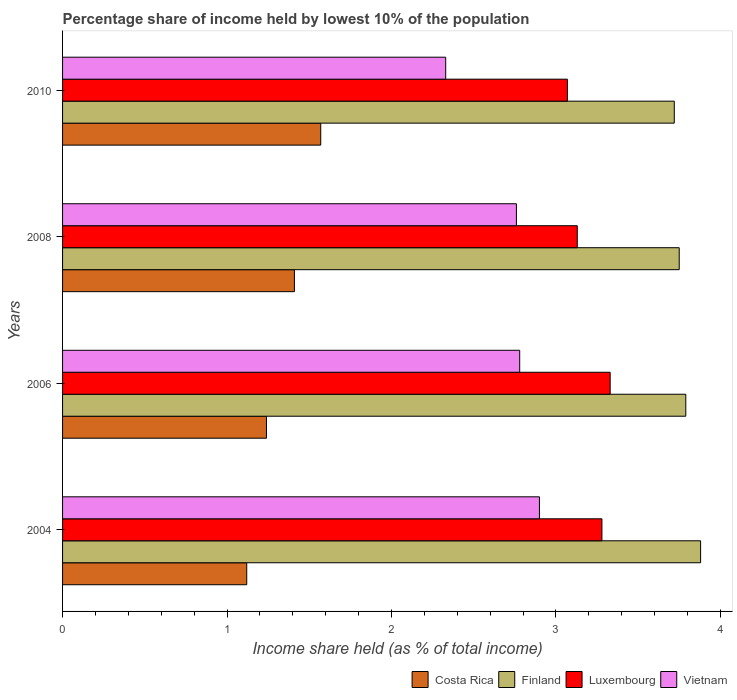How many different coloured bars are there?
Your answer should be very brief. 4. How many groups of bars are there?
Keep it short and to the point. 4. Are the number of bars per tick equal to the number of legend labels?
Your answer should be compact. Yes. Are the number of bars on each tick of the Y-axis equal?
Provide a short and direct response. Yes. How many bars are there on the 1st tick from the bottom?
Keep it short and to the point. 4. What is the label of the 2nd group of bars from the top?
Make the answer very short. 2008. What is the percentage share of income held by lowest 10% of the population in Costa Rica in 2004?
Provide a succinct answer. 1.12. Across all years, what is the maximum percentage share of income held by lowest 10% of the population in Vietnam?
Make the answer very short. 2.9. Across all years, what is the minimum percentage share of income held by lowest 10% of the population in Costa Rica?
Offer a terse response. 1.12. What is the total percentage share of income held by lowest 10% of the population in Finland in the graph?
Make the answer very short. 15.14. What is the difference between the percentage share of income held by lowest 10% of the population in Finland in 2006 and that in 2010?
Make the answer very short. 0.07. What is the difference between the percentage share of income held by lowest 10% of the population in Luxembourg in 2004 and the percentage share of income held by lowest 10% of the population in Finland in 2008?
Keep it short and to the point. -0.47. What is the average percentage share of income held by lowest 10% of the population in Luxembourg per year?
Ensure brevity in your answer.  3.2. In the year 2004, what is the difference between the percentage share of income held by lowest 10% of the population in Finland and percentage share of income held by lowest 10% of the population in Luxembourg?
Offer a terse response. 0.6. What is the ratio of the percentage share of income held by lowest 10% of the population in Costa Rica in 2008 to that in 2010?
Your answer should be very brief. 0.9. Is the percentage share of income held by lowest 10% of the population in Costa Rica in 2004 less than that in 2010?
Ensure brevity in your answer.  Yes. What is the difference between the highest and the second highest percentage share of income held by lowest 10% of the population in Luxembourg?
Your response must be concise. 0.05. What is the difference between the highest and the lowest percentage share of income held by lowest 10% of the population in Costa Rica?
Ensure brevity in your answer.  0.45. Is the sum of the percentage share of income held by lowest 10% of the population in Luxembourg in 2004 and 2008 greater than the maximum percentage share of income held by lowest 10% of the population in Vietnam across all years?
Your answer should be very brief. Yes. What does the 2nd bar from the bottom in 2004 represents?
Give a very brief answer. Finland. How many bars are there?
Your answer should be compact. 16. Are all the bars in the graph horizontal?
Your answer should be very brief. Yes. How many years are there in the graph?
Offer a very short reply. 4. Does the graph contain any zero values?
Your answer should be very brief. No. Does the graph contain grids?
Provide a short and direct response. No. How are the legend labels stacked?
Offer a terse response. Horizontal. What is the title of the graph?
Your answer should be very brief. Percentage share of income held by lowest 10% of the population. What is the label or title of the X-axis?
Your answer should be very brief. Income share held (as % of total income). What is the Income share held (as % of total income) of Costa Rica in 2004?
Give a very brief answer. 1.12. What is the Income share held (as % of total income) of Finland in 2004?
Provide a succinct answer. 3.88. What is the Income share held (as % of total income) in Luxembourg in 2004?
Make the answer very short. 3.28. What is the Income share held (as % of total income) in Costa Rica in 2006?
Your answer should be compact. 1.24. What is the Income share held (as % of total income) in Finland in 2006?
Make the answer very short. 3.79. What is the Income share held (as % of total income) of Luxembourg in 2006?
Your answer should be very brief. 3.33. What is the Income share held (as % of total income) of Vietnam in 2006?
Provide a short and direct response. 2.78. What is the Income share held (as % of total income) of Costa Rica in 2008?
Provide a succinct answer. 1.41. What is the Income share held (as % of total income) in Finland in 2008?
Your response must be concise. 3.75. What is the Income share held (as % of total income) in Luxembourg in 2008?
Provide a short and direct response. 3.13. What is the Income share held (as % of total income) of Vietnam in 2008?
Ensure brevity in your answer.  2.76. What is the Income share held (as % of total income) of Costa Rica in 2010?
Your answer should be compact. 1.57. What is the Income share held (as % of total income) in Finland in 2010?
Your answer should be compact. 3.72. What is the Income share held (as % of total income) in Luxembourg in 2010?
Provide a succinct answer. 3.07. What is the Income share held (as % of total income) in Vietnam in 2010?
Ensure brevity in your answer.  2.33. Across all years, what is the maximum Income share held (as % of total income) in Costa Rica?
Provide a short and direct response. 1.57. Across all years, what is the maximum Income share held (as % of total income) in Finland?
Make the answer very short. 3.88. Across all years, what is the maximum Income share held (as % of total income) of Luxembourg?
Provide a succinct answer. 3.33. Across all years, what is the maximum Income share held (as % of total income) of Vietnam?
Your answer should be very brief. 2.9. Across all years, what is the minimum Income share held (as % of total income) in Costa Rica?
Give a very brief answer. 1.12. Across all years, what is the minimum Income share held (as % of total income) in Finland?
Ensure brevity in your answer.  3.72. Across all years, what is the minimum Income share held (as % of total income) of Luxembourg?
Provide a short and direct response. 3.07. Across all years, what is the minimum Income share held (as % of total income) of Vietnam?
Ensure brevity in your answer.  2.33. What is the total Income share held (as % of total income) in Costa Rica in the graph?
Ensure brevity in your answer.  5.34. What is the total Income share held (as % of total income) of Finland in the graph?
Ensure brevity in your answer.  15.14. What is the total Income share held (as % of total income) of Luxembourg in the graph?
Provide a short and direct response. 12.81. What is the total Income share held (as % of total income) in Vietnam in the graph?
Give a very brief answer. 10.77. What is the difference between the Income share held (as % of total income) in Costa Rica in 2004 and that in 2006?
Offer a very short reply. -0.12. What is the difference between the Income share held (as % of total income) of Finland in 2004 and that in 2006?
Your answer should be very brief. 0.09. What is the difference between the Income share held (as % of total income) in Vietnam in 2004 and that in 2006?
Give a very brief answer. 0.12. What is the difference between the Income share held (as % of total income) in Costa Rica in 2004 and that in 2008?
Ensure brevity in your answer.  -0.29. What is the difference between the Income share held (as % of total income) of Finland in 2004 and that in 2008?
Provide a short and direct response. 0.13. What is the difference between the Income share held (as % of total income) in Luxembourg in 2004 and that in 2008?
Give a very brief answer. 0.15. What is the difference between the Income share held (as % of total income) of Vietnam in 2004 and that in 2008?
Offer a very short reply. 0.14. What is the difference between the Income share held (as % of total income) in Costa Rica in 2004 and that in 2010?
Ensure brevity in your answer.  -0.45. What is the difference between the Income share held (as % of total income) in Finland in 2004 and that in 2010?
Your answer should be very brief. 0.16. What is the difference between the Income share held (as % of total income) in Luxembourg in 2004 and that in 2010?
Offer a terse response. 0.21. What is the difference between the Income share held (as % of total income) of Vietnam in 2004 and that in 2010?
Your answer should be compact. 0.57. What is the difference between the Income share held (as % of total income) in Costa Rica in 2006 and that in 2008?
Your response must be concise. -0.17. What is the difference between the Income share held (as % of total income) of Costa Rica in 2006 and that in 2010?
Your answer should be compact. -0.33. What is the difference between the Income share held (as % of total income) of Finland in 2006 and that in 2010?
Your answer should be very brief. 0.07. What is the difference between the Income share held (as % of total income) of Luxembourg in 2006 and that in 2010?
Offer a terse response. 0.26. What is the difference between the Income share held (as % of total income) of Vietnam in 2006 and that in 2010?
Your answer should be very brief. 0.45. What is the difference between the Income share held (as % of total income) of Costa Rica in 2008 and that in 2010?
Your response must be concise. -0.16. What is the difference between the Income share held (as % of total income) of Finland in 2008 and that in 2010?
Offer a terse response. 0.03. What is the difference between the Income share held (as % of total income) in Vietnam in 2008 and that in 2010?
Ensure brevity in your answer.  0.43. What is the difference between the Income share held (as % of total income) of Costa Rica in 2004 and the Income share held (as % of total income) of Finland in 2006?
Make the answer very short. -2.67. What is the difference between the Income share held (as % of total income) in Costa Rica in 2004 and the Income share held (as % of total income) in Luxembourg in 2006?
Provide a short and direct response. -2.21. What is the difference between the Income share held (as % of total income) in Costa Rica in 2004 and the Income share held (as % of total income) in Vietnam in 2006?
Ensure brevity in your answer.  -1.66. What is the difference between the Income share held (as % of total income) in Finland in 2004 and the Income share held (as % of total income) in Luxembourg in 2006?
Provide a short and direct response. 0.55. What is the difference between the Income share held (as % of total income) of Finland in 2004 and the Income share held (as % of total income) of Vietnam in 2006?
Your answer should be compact. 1.1. What is the difference between the Income share held (as % of total income) in Luxembourg in 2004 and the Income share held (as % of total income) in Vietnam in 2006?
Give a very brief answer. 0.5. What is the difference between the Income share held (as % of total income) of Costa Rica in 2004 and the Income share held (as % of total income) of Finland in 2008?
Provide a short and direct response. -2.63. What is the difference between the Income share held (as % of total income) of Costa Rica in 2004 and the Income share held (as % of total income) of Luxembourg in 2008?
Ensure brevity in your answer.  -2.01. What is the difference between the Income share held (as % of total income) of Costa Rica in 2004 and the Income share held (as % of total income) of Vietnam in 2008?
Give a very brief answer. -1.64. What is the difference between the Income share held (as % of total income) of Finland in 2004 and the Income share held (as % of total income) of Vietnam in 2008?
Provide a succinct answer. 1.12. What is the difference between the Income share held (as % of total income) in Luxembourg in 2004 and the Income share held (as % of total income) in Vietnam in 2008?
Offer a terse response. 0.52. What is the difference between the Income share held (as % of total income) of Costa Rica in 2004 and the Income share held (as % of total income) of Luxembourg in 2010?
Offer a very short reply. -1.95. What is the difference between the Income share held (as % of total income) in Costa Rica in 2004 and the Income share held (as % of total income) in Vietnam in 2010?
Offer a terse response. -1.21. What is the difference between the Income share held (as % of total income) of Finland in 2004 and the Income share held (as % of total income) of Luxembourg in 2010?
Ensure brevity in your answer.  0.81. What is the difference between the Income share held (as % of total income) in Finland in 2004 and the Income share held (as % of total income) in Vietnam in 2010?
Your answer should be very brief. 1.55. What is the difference between the Income share held (as % of total income) of Costa Rica in 2006 and the Income share held (as % of total income) of Finland in 2008?
Your answer should be very brief. -2.51. What is the difference between the Income share held (as % of total income) of Costa Rica in 2006 and the Income share held (as % of total income) of Luxembourg in 2008?
Ensure brevity in your answer.  -1.89. What is the difference between the Income share held (as % of total income) of Costa Rica in 2006 and the Income share held (as % of total income) of Vietnam in 2008?
Your answer should be compact. -1.52. What is the difference between the Income share held (as % of total income) of Finland in 2006 and the Income share held (as % of total income) of Luxembourg in 2008?
Provide a short and direct response. 0.66. What is the difference between the Income share held (as % of total income) in Finland in 2006 and the Income share held (as % of total income) in Vietnam in 2008?
Provide a succinct answer. 1.03. What is the difference between the Income share held (as % of total income) of Luxembourg in 2006 and the Income share held (as % of total income) of Vietnam in 2008?
Offer a very short reply. 0.57. What is the difference between the Income share held (as % of total income) in Costa Rica in 2006 and the Income share held (as % of total income) in Finland in 2010?
Provide a succinct answer. -2.48. What is the difference between the Income share held (as % of total income) of Costa Rica in 2006 and the Income share held (as % of total income) of Luxembourg in 2010?
Give a very brief answer. -1.83. What is the difference between the Income share held (as % of total income) in Costa Rica in 2006 and the Income share held (as % of total income) in Vietnam in 2010?
Offer a very short reply. -1.09. What is the difference between the Income share held (as % of total income) in Finland in 2006 and the Income share held (as % of total income) in Luxembourg in 2010?
Provide a succinct answer. 0.72. What is the difference between the Income share held (as % of total income) in Finland in 2006 and the Income share held (as % of total income) in Vietnam in 2010?
Your answer should be very brief. 1.46. What is the difference between the Income share held (as % of total income) of Luxembourg in 2006 and the Income share held (as % of total income) of Vietnam in 2010?
Your answer should be compact. 1. What is the difference between the Income share held (as % of total income) of Costa Rica in 2008 and the Income share held (as % of total income) of Finland in 2010?
Offer a terse response. -2.31. What is the difference between the Income share held (as % of total income) of Costa Rica in 2008 and the Income share held (as % of total income) of Luxembourg in 2010?
Your answer should be very brief. -1.66. What is the difference between the Income share held (as % of total income) in Costa Rica in 2008 and the Income share held (as % of total income) in Vietnam in 2010?
Give a very brief answer. -0.92. What is the difference between the Income share held (as % of total income) in Finland in 2008 and the Income share held (as % of total income) in Luxembourg in 2010?
Make the answer very short. 0.68. What is the difference between the Income share held (as % of total income) of Finland in 2008 and the Income share held (as % of total income) of Vietnam in 2010?
Your answer should be very brief. 1.42. What is the average Income share held (as % of total income) of Costa Rica per year?
Provide a succinct answer. 1.33. What is the average Income share held (as % of total income) of Finland per year?
Your answer should be compact. 3.79. What is the average Income share held (as % of total income) in Luxembourg per year?
Provide a succinct answer. 3.2. What is the average Income share held (as % of total income) of Vietnam per year?
Give a very brief answer. 2.69. In the year 2004, what is the difference between the Income share held (as % of total income) of Costa Rica and Income share held (as % of total income) of Finland?
Ensure brevity in your answer.  -2.76. In the year 2004, what is the difference between the Income share held (as % of total income) in Costa Rica and Income share held (as % of total income) in Luxembourg?
Provide a succinct answer. -2.16. In the year 2004, what is the difference between the Income share held (as % of total income) of Costa Rica and Income share held (as % of total income) of Vietnam?
Offer a very short reply. -1.78. In the year 2004, what is the difference between the Income share held (as % of total income) in Luxembourg and Income share held (as % of total income) in Vietnam?
Your answer should be compact. 0.38. In the year 2006, what is the difference between the Income share held (as % of total income) in Costa Rica and Income share held (as % of total income) in Finland?
Provide a short and direct response. -2.55. In the year 2006, what is the difference between the Income share held (as % of total income) of Costa Rica and Income share held (as % of total income) of Luxembourg?
Give a very brief answer. -2.09. In the year 2006, what is the difference between the Income share held (as % of total income) in Costa Rica and Income share held (as % of total income) in Vietnam?
Provide a short and direct response. -1.54. In the year 2006, what is the difference between the Income share held (as % of total income) of Finland and Income share held (as % of total income) of Luxembourg?
Provide a short and direct response. 0.46. In the year 2006, what is the difference between the Income share held (as % of total income) in Finland and Income share held (as % of total income) in Vietnam?
Make the answer very short. 1.01. In the year 2006, what is the difference between the Income share held (as % of total income) of Luxembourg and Income share held (as % of total income) of Vietnam?
Provide a succinct answer. 0.55. In the year 2008, what is the difference between the Income share held (as % of total income) of Costa Rica and Income share held (as % of total income) of Finland?
Offer a very short reply. -2.34. In the year 2008, what is the difference between the Income share held (as % of total income) of Costa Rica and Income share held (as % of total income) of Luxembourg?
Make the answer very short. -1.72. In the year 2008, what is the difference between the Income share held (as % of total income) in Costa Rica and Income share held (as % of total income) in Vietnam?
Give a very brief answer. -1.35. In the year 2008, what is the difference between the Income share held (as % of total income) in Finland and Income share held (as % of total income) in Luxembourg?
Your response must be concise. 0.62. In the year 2008, what is the difference between the Income share held (as % of total income) of Luxembourg and Income share held (as % of total income) of Vietnam?
Make the answer very short. 0.37. In the year 2010, what is the difference between the Income share held (as % of total income) of Costa Rica and Income share held (as % of total income) of Finland?
Give a very brief answer. -2.15. In the year 2010, what is the difference between the Income share held (as % of total income) of Costa Rica and Income share held (as % of total income) of Luxembourg?
Offer a very short reply. -1.5. In the year 2010, what is the difference between the Income share held (as % of total income) of Costa Rica and Income share held (as % of total income) of Vietnam?
Provide a succinct answer. -0.76. In the year 2010, what is the difference between the Income share held (as % of total income) in Finland and Income share held (as % of total income) in Luxembourg?
Your response must be concise. 0.65. In the year 2010, what is the difference between the Income share held (as % of total income) in Finland and Income share held (as % of total income) in Vietnam?
Provide a short and direct response. 1.39. In the year 2010, what is the difference between the Income share held (as % of total income) of Luxembourg and Income share held (as % of total income) of Vietnam?
Your response must be concise. 0.74. What is the ratio of the Income share held (as % of total income) of Costa Rica in 2004 to that in 2006?
Make the answer very short. 0.9. What is the ratio of the Income share held (as % of total income) of Finland in 2004 to that in 2006?
Give a very brief answer. 1.02. What is the ratio of the Income share held (as % of total income) in Luxembourg in 2004 to that in 2006?
Ensure brevity in your answer.  0.98. What is the ratio of the Income share held (as % of total income) of Vietnam in 2004 to that in 2006?
Offer a terse response. 1.04. What is the ratio of the Income share held (as % of total income) in Costa Rica in 2004 to that in 2008?
Your answer should be very brief. 0.79. What is the ratio of the Income share held (as % of total income) of Finland in 2004 to that in 2008?
Offer a very short reply. 1.03. What is the ratio of the Income share held (as % of total income) in Luxembourg in 2004 to that in 2008?
Keep it short and to the point. 1.05. What is the ratio of the Income share held (as % of total income) of Vietnam in 2004 to that in 2008?
Your answer should be very brief. 1.05. What is the ratio of the Income share held (as % of total income) of Costa Rica in 2004 to that in 2010?
Your response must be concise. 0.71. What is the ratio of the Income share held (as % of total income) in Finland in 2004 to that in 2010?
Offer a terse response. 1.04. What is the ratio of the Income share held (as % of total income) in Luxembourg in 2004 to that in 2010?
Make the answer very short. 1.07. What is the ratio of the Income share held (as % of total income) in Vietnam in 2004 to that in 2010?
Your response must be concise. 1.24. What is the ratio of the Income share held (as % of total income) in Costa Rica in 2006 to that in 2008?
Ensure brevity in your answer.  0.88. What is the ratio of the Income share held (as % of total income) in Finland in 2006 to that in 2008?
Offer a very short reply. 1.01. What is the ratio of the Income share held (as % of total income) of Luxembourg in 2006 to that in 2008?
Your answer should be compact. 1.06. What is the ratio of the Income share held (as % of total income) of Vietnam in 2006 to that in 2008?
Offer a terse response. 1.01. What is the ratio of the Income share held (as % of total income) of Costa Rica in 2006 to that in 2010?
Give a very brief answer. 0.79. What is the ratio of the Income share held (as % of total income) of Finland in 2006 to that in 2010?
Keep it short and to the point. 1.02. What is the ratio of the Income share held (as % of total income) of Luxembourg in 2006 to that in 2010?
Your answer should be compact. 1.08. What is the ratio of the Income share held (as % of total income) in Vietnam in 2006 to that in 2010?
Make the answer very short. 1.19. What is the ratio of the Income share held (as % of total income) in Costa Rica in 2008 to that in 2010?
Keep it short and to the point. 0.9. What is the ratio of the Income share held (as % of total income) of Finland in 2008 to that in 2010?
Provide a succinct answer. 1.01. What is the ratio of the Income share held (as % of total income) of Luxembourg in 2008 to that in 2010?
Keep it short and to the point. 1.02. What is the ratio of the Income share held (as % of total income) of Vietnam in 2008 to that in 2010?
Ensure brevity in your answer.  1.18. What is the difference between the highest and the second highest Income share held (as % of total income) of Costa Rica?
Provide a succinct answer. 0.16. What is the difference between the highest and the second highest Income share held (as % of total income) in Finland?
Keep it short and to the point. 0.09. What is the difference between the highest and the second highest Income share held (as % of total income) in Luxembourg?
Give a very brief answer. 0.05. What is the difference between the highest and the second highest Income share held (as % of total income) in Vietnam?
Make the answer very short. 0.12. What is the difference between the highest and the lowest Income share held (as % of total income) in Costa Rica?
Keep it short and to the point. 0.45. What is the difference between the highest and the lowest Income share held (as % of total income) in Finland?
Provide a short and direct response. 0.16. What is the difference between the highest and the lowest Income share held (as % of total income) of Luxembourg?
Offer a terse response. 0.26. What is the difference between the highest and the lowest Income share held (as % of total income) in Vietnam?
Make the answer very short. 0.57. 